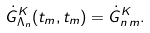<formula> <loc_0><loc_0><loc_500><loc_500>\dot { G } ^ { K } _ { \Lambda _ { n } } ( t _ { m } , t _ { m } ) = \dot { G } ^ { K } _ { n \, m } .</formula> 